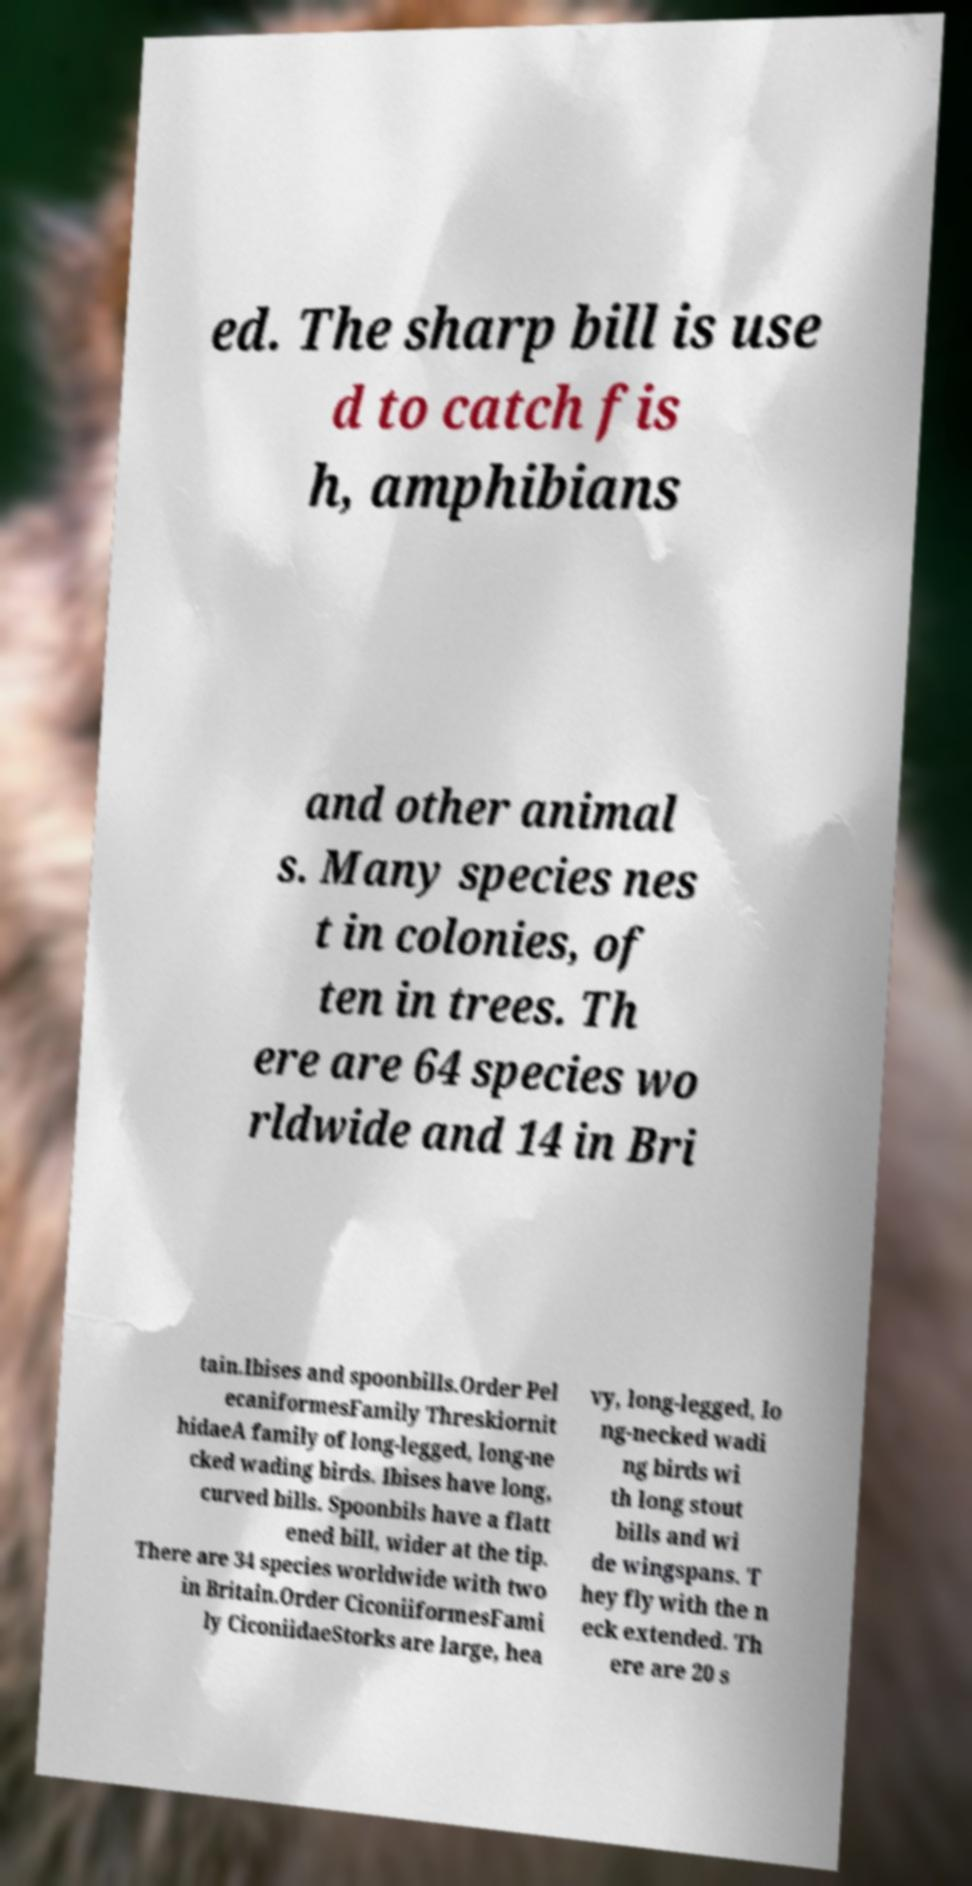Can you accurately transcribe the text from the provided image for me? ed. The sharp bill is use d to catch fis h, amphibians and other animal s. Many species nes t in colonies, of ten in trees. Th ere are 64 species wo rldwide and 14 in Bri tain.Ibises and spoonbills.Order Pel ecaniformesFamily Threskiornit hidaeA family of long-legged, long-ne cked wading birds. Ibises have long, curved bills. Spoonbils have a flatt ened bill, wider at the tip. There are 34 species worldwide with two in Britain.Order CiconiiformesFami ly CiconiidaeStorks are large, hea vy, long-legged, lo ng-necked wadi ng birds wi th long stout bills and wi de wingspans. T hey fly with the n eck extended. Th ere are 20 s 